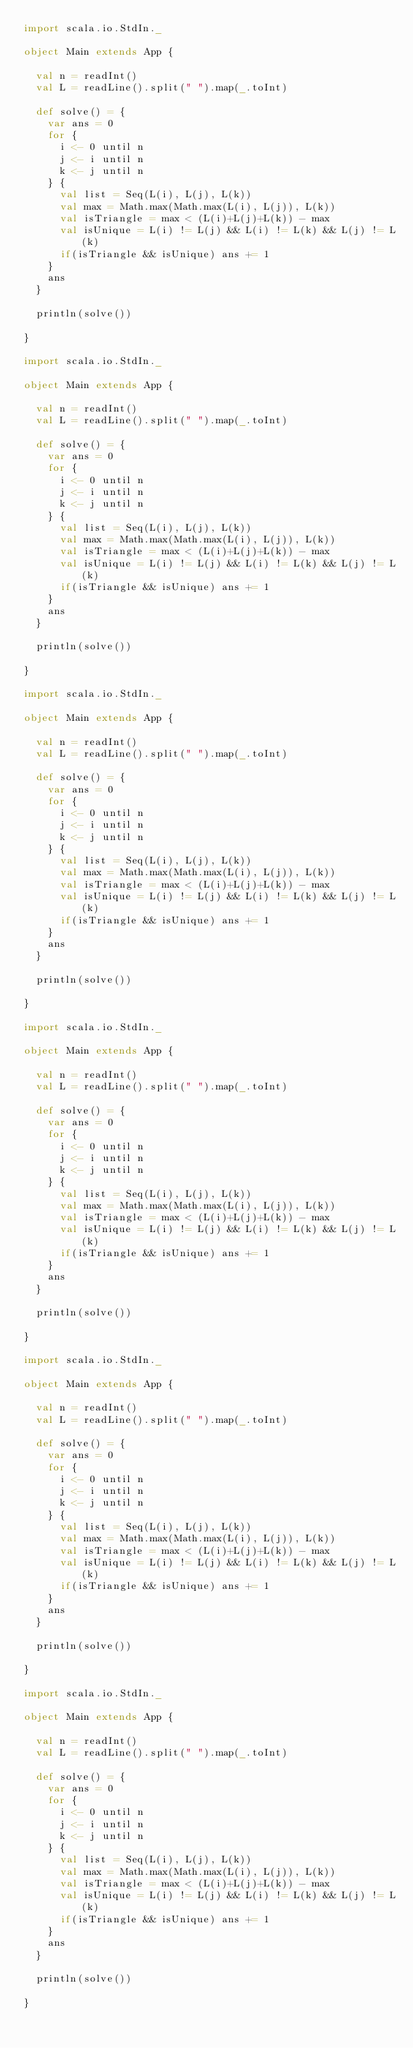<code> <loc_0><loc_0><loc_500><loc_500><_Scala_>import scala.io.StdIn._

object Main extends App {

  val n = readInt()
  val L = readLine().split(" ").map(_.toInt)

  def solve() = {
    var ans = 0
    for {
      i <- 0 until n
      j <- i until n
      k <- j until n
    } {
      val list = Seq(L(i), L(j), L(k))
      val max = Math.max(Math.max(L(i), L(j)), L(k))
      val isTriangle = max < (L(i)+L(j)+L(k)) - max
      val isUnique = L(i) != L(j) && L(i) != L(k) && L(j) != L(k)
      if(isTriangle && isUnique) ans += 1
    }
    ans
  }

  println(solve())

}

import scala.io.StdIn._

object Main extends App {

  val n = readInt()
  val L = readLine().split(" ").map(_.toInt)

  def solve() = {
    var ans = 0
    for {
      i <- 0 until n
      j <- i until n
      k <- j until n
    } {
      val list = Seq(L(i), L(j), L(k))
      val max = Math.max(Math.max(L(i), L(j)), L(k))
      val isTriangle = max < (L(i)+L(j)+L(k)) - max
      val isUnique = L(i) != L(j) && L(i) != L(k) && L(j) != L(k)
      if(isTriangle && isUnique) ans += 1
    }
    ans
  }

  println(solve())

}

import scala.io.StdIn._

object Main extends App {

  val n = readInt()
  val L = readLine().split(" ").map(_.toInt)

  def solve() = {
    var ans = 0
    for {
      i <- 0 until n
      j <- i until n
      k <- j until n
    } {
      val list = Seq(L(i), L(j), L(k))
      val max = Math.max(Math.max(L(i), L(j)), L(k))
      val isTriangle = max < (L(i)+L(j)+L(k)) - max
      val isUnique = L(i) != L(j) && L(i) != L(k) && L(j) != L(k)
      if(isTriangle && isUnique) ans += 1
    }
    ans
  }

  println(solve())

}

import scala.io.StdIn._

object Main extends App {

  val n = readInt()
  val L = readLine().split(" ").map(_.toInt)

  def solve() = {
    var ans = 0
    for {
      i <- 0 until n
      j <- i until n
      k <- j until n
    } {
      val list = Seq(L(i), L(j), L(k))
      val max = Math.max(Math.max(L(i), L(j)), L(k))
      val isTriangle = max < (L(i)+L(j)+L(k)) - max
      val isUnique = L(i) != L(j) && L(i) != L(k) && L(j) != L(k)
      if(isTriangle && isUnique) ans += 1
    }
    ans
  }

  println(solve())

}

import scala.io.StdIn._

object Main extends App {

  val n = readInt()
  val L = readLine().split(" ").map(_.toInt)

  def solve() = {
    var ans = 0
    for {
      i <- 0 until n
      j <- i until n
      k <- j until n
    } {
      val list = Seq(L(i), L(j), L(k))
      val max = Math.max(Math.max(L(i), L(j)), L(k))
      val isTriangle = max < (L(i)+L(j)+L(k)) - max
      val isUnique = L(i) != L(j) && L(i) != L(k) && L(j) != L(k)
      if(isTriangle && isUnique) ans += 1
    }
    ans
  }

  println(solve())

}

import scala.io.StdIn._

object Main extends App {

  val n = readInt()
  val L = readLine().split(" ").map(_.toInt)

  def solve() = {
    var ans = 0
    for {
      i <- 0 until n
      j <- i until n
      k <- j until n
    } {
      val list = Seq(L(i), L(j), L(k))
      val max = Math.max(Math.max(L(i), L(j)), L(k))
      val isTriangle = max < (L(i)+L(j)+L(k)) - max
      val isUnique = L(i) != L(j) && L(i) != L(k) && L(j) != L(k)
      if(isTriangle && isUnique) ans += 1
    }
    ans
  }

  println(solve())

}

</code> 